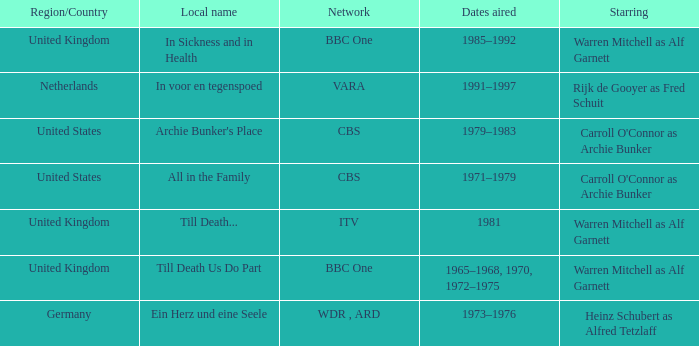Who was the star for the Vara network? Rijk de Gooyer as Fred Schuit. 